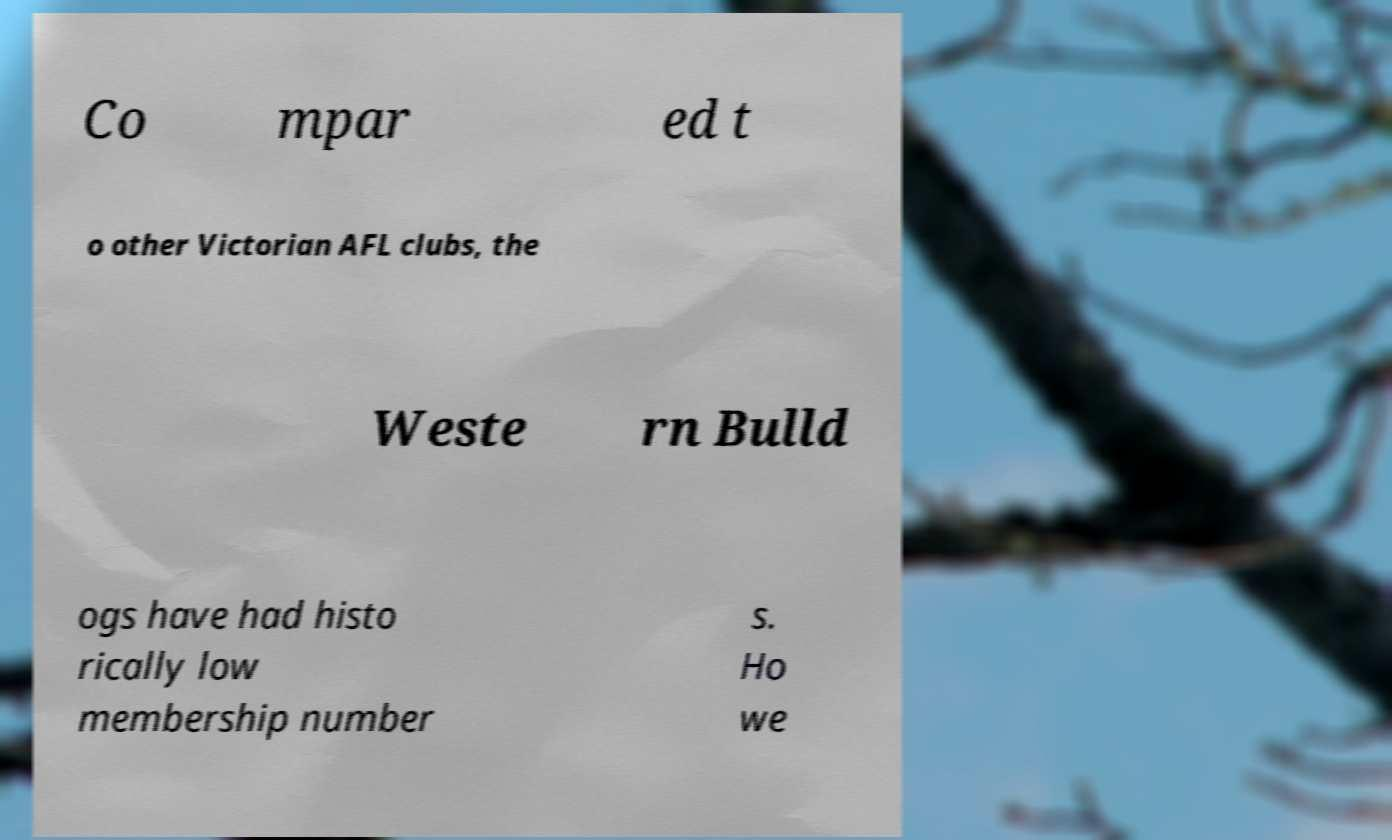I need the written content from this picture converted into text. Can you do that? Co mpar ed t o other Victorian AFL clubs, the  Weste rn Bulld ogs have had histo rically low membership number s. Ho we 